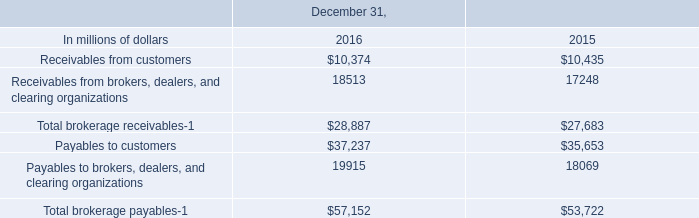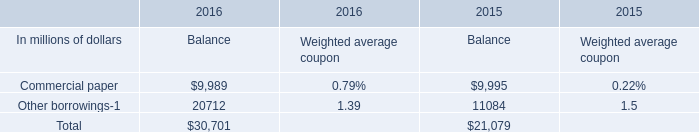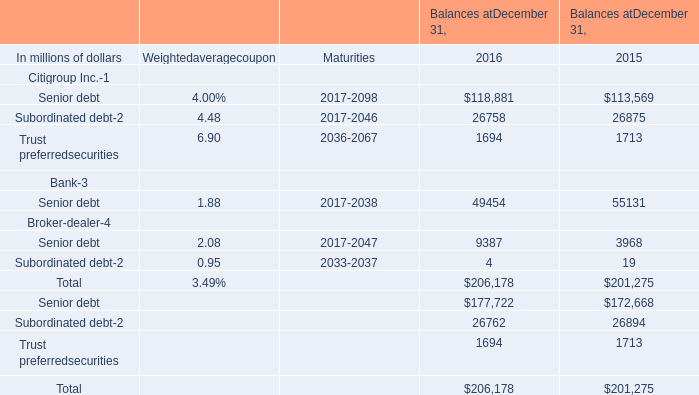What is the sum of the Subordinated debt in the years where Senior debt for Citigroup Inc. is greater than 118000? (in million) 
Computations: (26758 + 4)
Answer: 26762.0. 